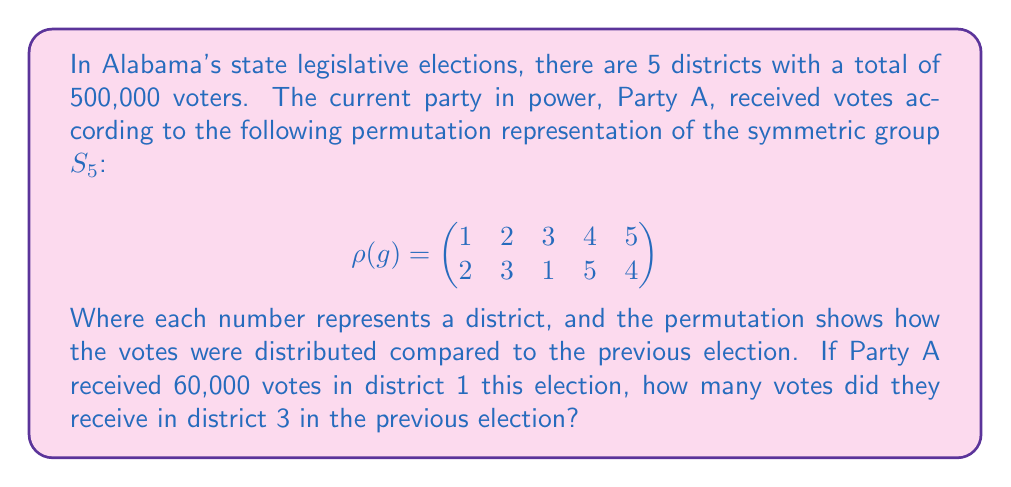What is the answer to this math problem? Let's approach this step-by-step:

1) First, we need to understand what the permutation representation means:
   $$\rho(g) = \begin{pmatrix}
   1 & 2 & 3 & 4 & 5 \\
   2 & 3 & 1 & 5 & 4
   \end{pmatrix}$$
   This shows how votes moved between districts from the previous election to the current one.

2) We're told that Party A received 60,000 votes in district 1 in the current election.

3) Looking at the permutation, we see that 1 maps to 2. This means that the votes now in district 1 came from district 2 in the previous election.

4) We want to know about district 3 in the previous election. In the permutation, we see that 3 maps to 1.

5) This means that the votes that were in district 3 in the previous election are now in district 1 in the current election.

6) Since district 1 in the current election has 60,000 votes, we can conclude that district 3 in the previous election also had 60,000 votes.

This demonstrates how group theory, specifically permutation groups, can be used to analyze vote distribution across districts over time.
Answer: 60,000 votes 